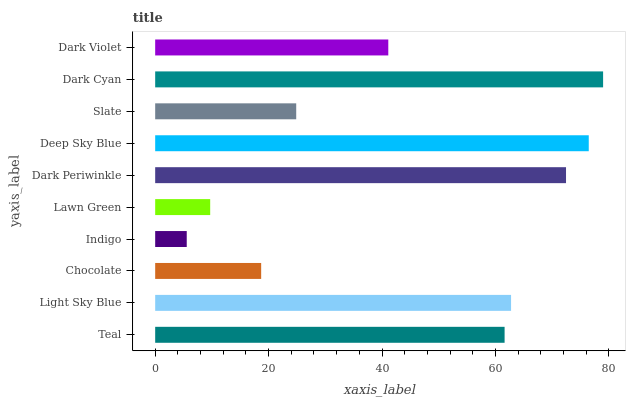Is Indigo the minimum?
Answer yes or no. Yes. Is Dark Cyan the maximum?
Answer yes or no. Yes. Is Light Sky Blue the minimum?
Answer yes or no. No. Is Light Sky Blue the maximum?
Answer yes or no. No. Is Light Sky Blue greater than Teal?
Answer yes or no. Yes. Is Teal less than Light Sky Blue?
Answer yes or no. Yes. Is Teal greater than Light Sky Blue?
Answer yes or no. No. Is Light Sky Blue less than Teal?
Answer yes or no. No. Is Teal the high median?
Answer yes or no. Yes. Is Dark Violet the low median?
Answer yes or no. Yes. Is Light Sky Blue the high median?
Answer yes or no. No. Is Light Sky Blue the low median?
Answer yes or no. No. 